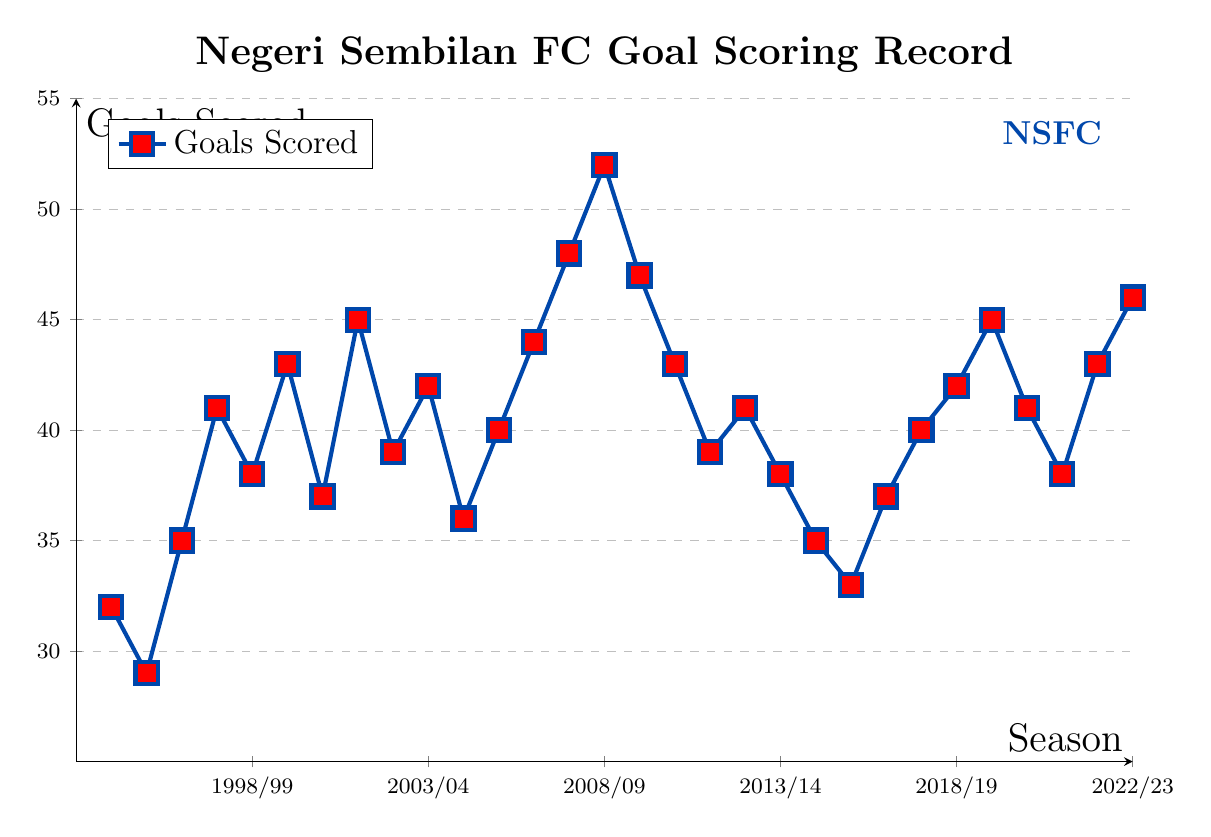What season saw the highest number of goals scored? The highest point on the plot corresponds to the 2007/08 season, where the line reaches 52 goals.
Answer: 2007/08 How many seasons had a goal score of more than 40 but less than 45? The plot shows that the seasons 1997/98, 2000/01, 2002/03, 2004/05, 2005/06, 2009/10, 2011/12, 2016/17, and 2019/20 had goals within this range, totaling 9 seasons.
Answer: 9 Which seasons experienced a decrease in goals compared to the previous season? List them. From the plot, the seasons with decreases are 1994/95, 1997/98, 1999/00, 2001/02, 2003/04, 2008/09, 2010/11, 2013/14, 2015/16, 2020/21.
Answer: 1994/95, 1997/98, 1999/00, 2001/02, 2003/04, 2008/09, 2010/11, 2013/14, 2015/16, 2020/21 What is the average number of goals scored over the 30 seasons? The sum of goals over 30 seasons is \(32 + 29 + 35 + 41 + 38 + 43 + 37 + 45 + 39 + 42 + 36 + 40 + 44 + 48 + 52 + 47 + 43 + 39 + 41 + 38 + 35 + 33 + 37 + 40 + 42 + 45 + 41 + 38 + 43 + 46 = 1198\). The average is 1198/30.
Answer: 39.93 How does the number of goals scored in the 2022/23 season compare to the 1998/99 season? In 2022/23, the number of goals scored is 46, while in 1998/99 it is 43. Thus, there were 3 more goals scored in 2022/23 compared to 1998/99.
Answer: 3 more What is the trend of goals scored from 2005/06 to 2007/08? From 2005/06 to 2007/08, the number of goals increased each season: from 44 in 2005/06 to 48 in 2006/07, and then to 52 in 2007/08.
Answer: Increasing Which season had an equal number of goals as the 2015/16 season? The plot shows that both the 1999/00 and 2015/16 seasons had 37 goals.
Answer: 1999/00 